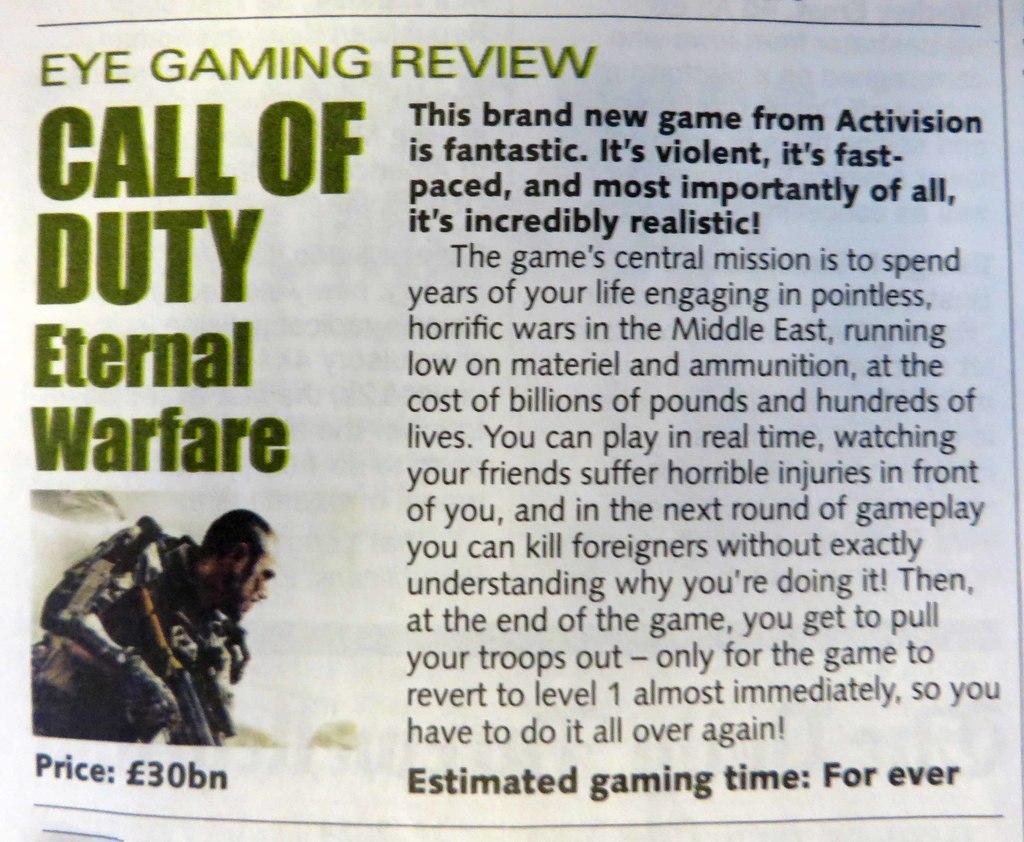<image>
Provide a brief description of the given image. An informational review for the game call of duty Eternal warfare 